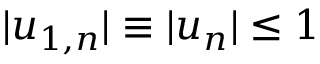Convert formula to latex. <formula><loc_0><loc_0><loc_500><loc_500>| { u } _ { 1 , n } | \equiv | { u } _ { n } | \leq 1</formula> 